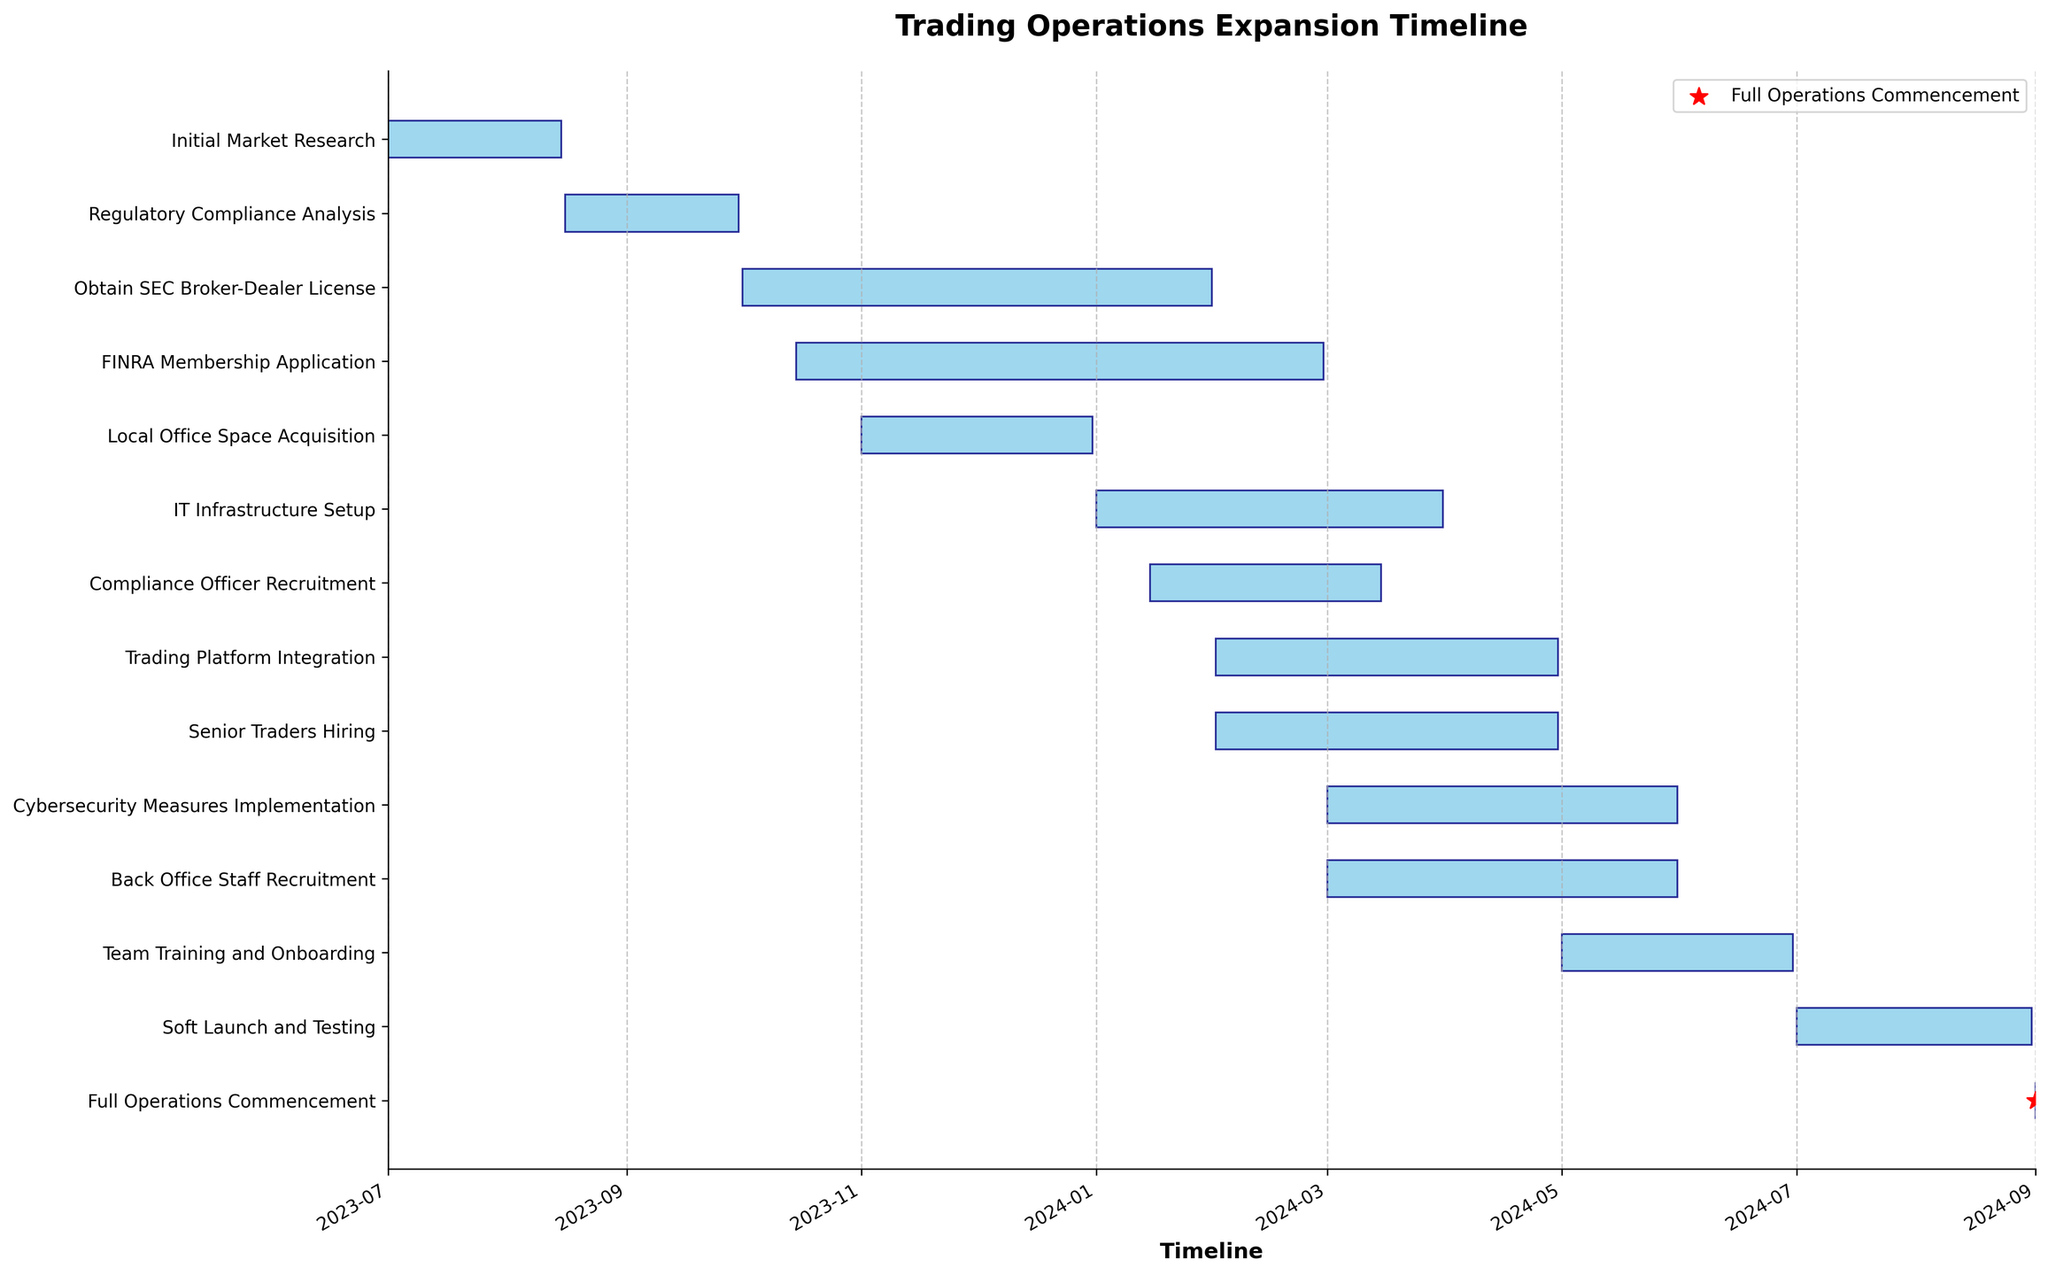How long is the Initial Market Research phase? To determine the duration, look at the start and end dates for the Initial Market Research phase. It starts on July 1, 2023, and ends on August 15, 2023. Subtract the start date from the end date to get the number of days: August 15 - July 1 = 45 days.
Answer: 45 days What is the title of the figure? The title of the figure can be found at the top, centered above the chart. It is usually in a larger and bold font to draw attention.
Answer: Trading Operations Expansion Timeline Which task is marked with a special milestone symbol? To find tasks marked with special symbols, look at the chart for any standout markers. Here, the "Full Operations Commencement" task is marked with a red star.
Answer: Full Operations Commencement When does the IT Infrastructure Setup phase end? Look at the end date of the IT Infrastructure Setup phase on the Gantt chart. The task bar labeled "IT Infrastructure Setup" ends on March 31, 2024.
Answer: March 31, 2024 How many tasks are there that start in 2023? To determine the number of tasks starting in 2023, check the start dates of each task in the chart. Count tasks with start dates within the year 2023. There are five such tasks: Initial Market Research, Regulatory Compliance Analysis, Obtain SEC Broker-Dealer License, FINRA Membership Application, and Local Office Space Acquisition.
Answer: 5 Which task has the shortest duration, and how long is it? To find the shortest duration, compare the lengths of all task bars. The "Full Operations Commencement" has the shortest duration with a single day shown by a short bar.
Answer: Full Operations Commencement, 1 day What are the tasks that overlap during February 2024? Look at tasks whose duration bars cover February 2024. These are: Obtain SEC Broker-Dealer License, FINRA Membership Application, IT Infrastructure Setup, Trading Platform Integration, Compliance Officer Recruitment, and Senior Traders Hiring.
Answer: Six tasks: Obtain SEC Broker-Dealer License, FINRA Membership Application, IT Infrastructure Setup, Trading Platform Integration, Compliance Officer Recruitment, Senior Traders Hiring Which task ends first in 2024? Check the end dates of tasks that conclude in 2024. The first one that ends is the "Local Office Space Acquisition," which completes on January 31, 2024.
Answer: Local Office Space Acquisition What is the total duration needed from the start of Initial Market Research to Full Operations Commencement? Identify the start date of the Initial Market Research (July 1, 2023) and the start date (commencement) of Full Operations (September 1, 2024). Calculate the total duration between these dates. From July 1, 2023, to September 1, 2024, it covers 428 days.
Answer: 428 days 